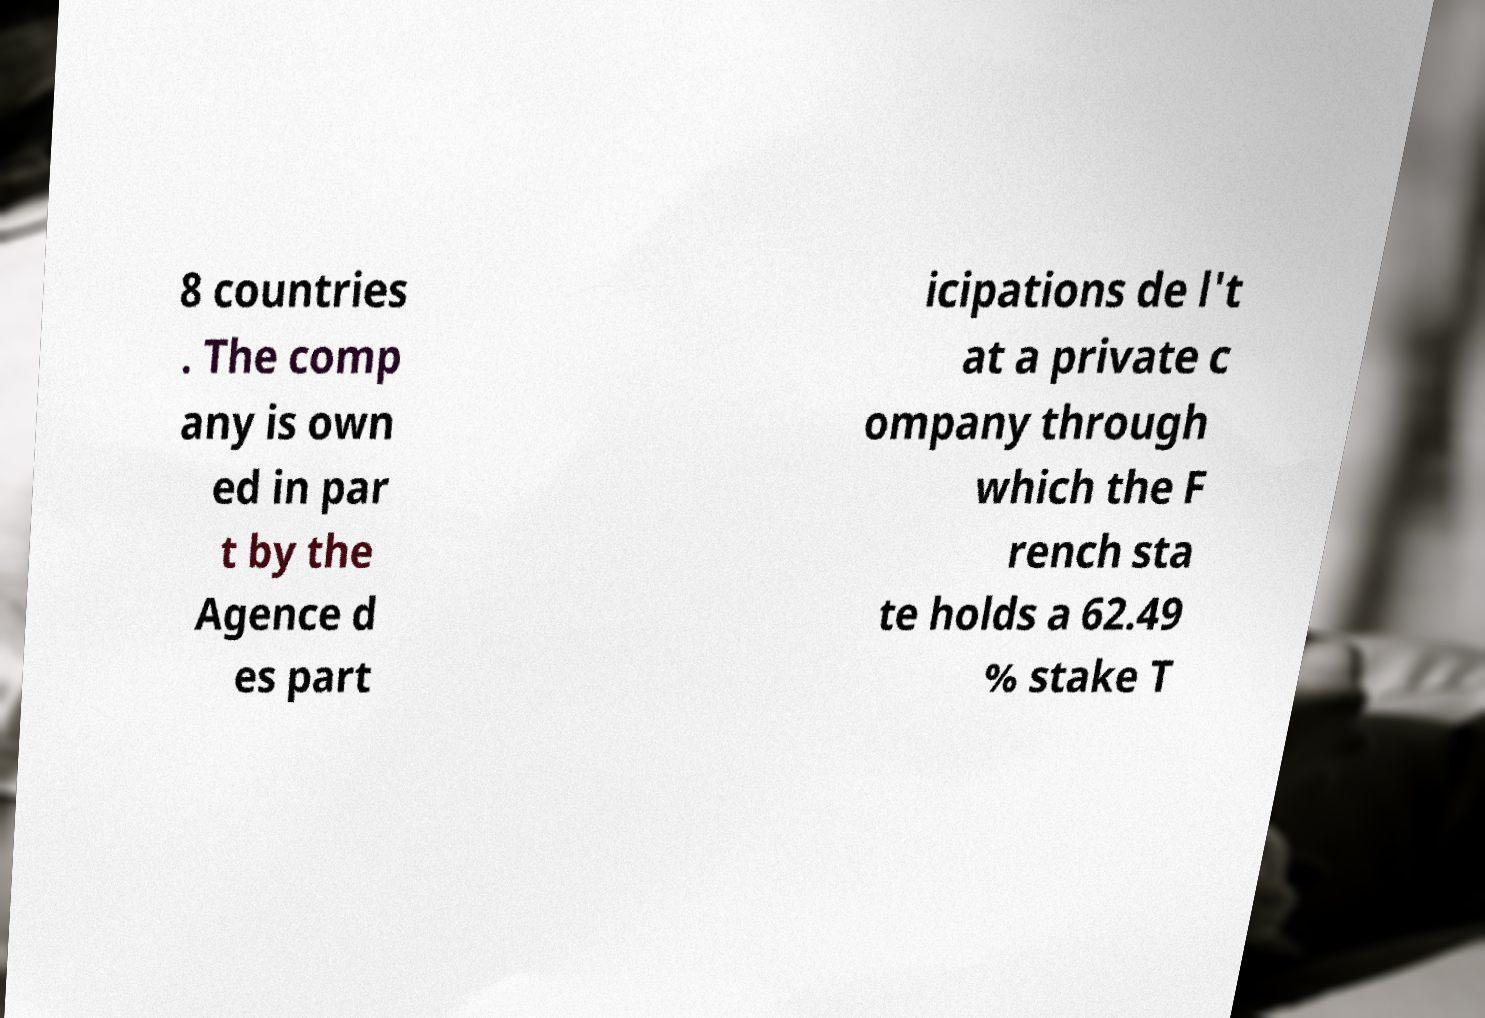Could you extract and type out the text from this image? 8 countries . The comp any is own ed in par t by the Agence d es part icipations de l't at a private c ompany through which the F rench sta te holds a 62.49 % stake T 